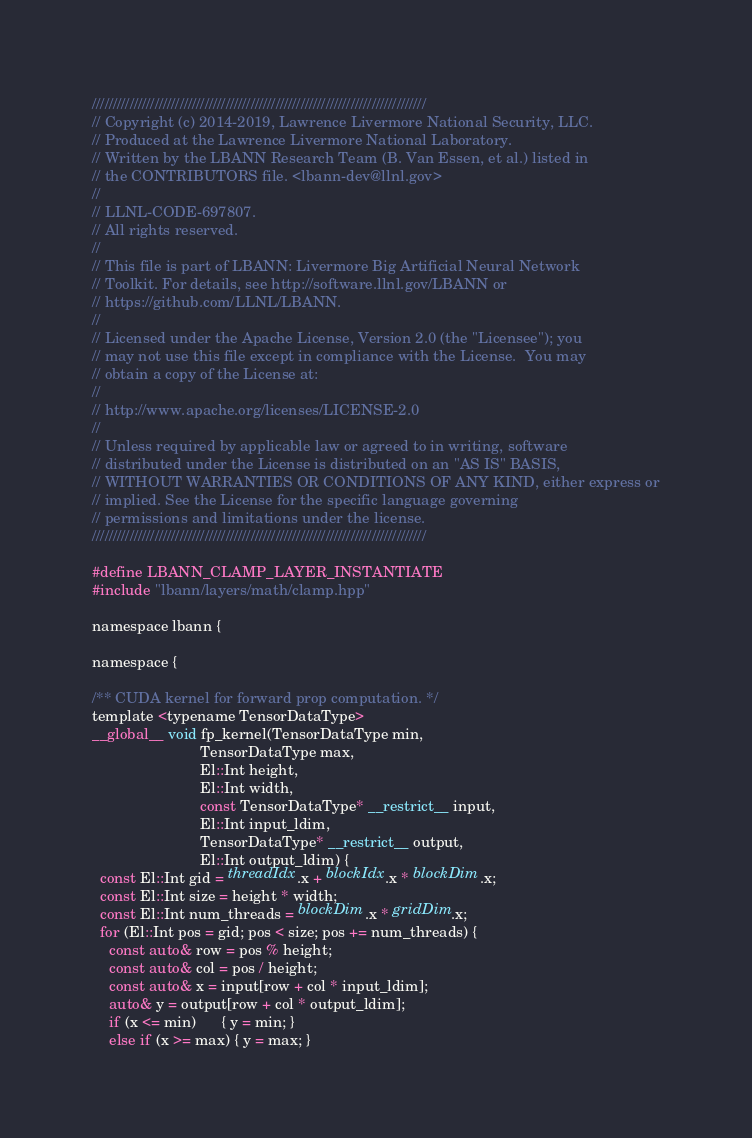Convert code to text. <code><loc_0><loc_0><loc_500><loc_500><_Cuda_>////////////////////////////////////////////////////////////////////////////////
// Copyright (c) 2014-2019, Lawrence Livermore National Security, LLC.
// Produced at the Lawrence Livermore National Laboratory.
// Written by the LBANN Research Team (B. Van Essen, et al.) listed in
// the CONTRIBUTORS file. <lbann-dev@llnl.gov>
//
// LLNL-CODE-697807.
// All rights reserved.
//
// This file is part of LBANN: Livermore Big Artificial Neural Network
// Toolkit. For details, see http://software.llnl.gov/LBANN or
// https://github.com/LLNL/LBANN.
//
// Licensed under the Apache License, Version 2.0 (the "Licensee"); you
// may not use this file except in compliance with the License.  You may
// obtain a copy of the License at:
//
// http://www.apache.org/licenses/LICENSE-2.0
//
// Unless required by applicable law or agreed to in writing, software
// distributed under the License is distributed on an "AS IS" BASIS,
// WITHOUT WARRANTIES OR CONDITIONS OF ANY KIND, either express or
// implied. See the License for the specific language governing
// permissions and limitations under the license.
////////////////////////////////////////////////////////////////////////////////

#define LBANN_CLAMP_LAYER_INSTANTIATE
#include "lbann/layers/math/clamp.hpp"

namespace lbann {

namespace {

/** CUDA kernel for forward prop computation. */
template <typename TensorDataType>
__global__ void fp_kernel(TensorDataType min,
                          TensorDataType max,
                          El::Int height,
                          El::Int width,
                          const TensorDataType* __restrict__ input,
                          El::Int input_ldim,
                          TensorDataType* __restrict__ output,
                          El::Int output_ldim) {
  const El::Int gid = threadIdx.x + blockIdx.x * blockDim.x;
  const El::Int size = height * width;
  const El::Int num_threads = blockDim.x * gridDim.x;
  for (El::Int pos = gid; pos < size; pos += num_threads) {
    const auto& row = pos % height;
    const auto& col = pos / height;
    const auto& x = input[row + col * input_ldim];
    auto& y = output[row + col * output_ldim];
    if (x <= min)      { y = min; }
    else if (x >= max) { y = max; }</code> 